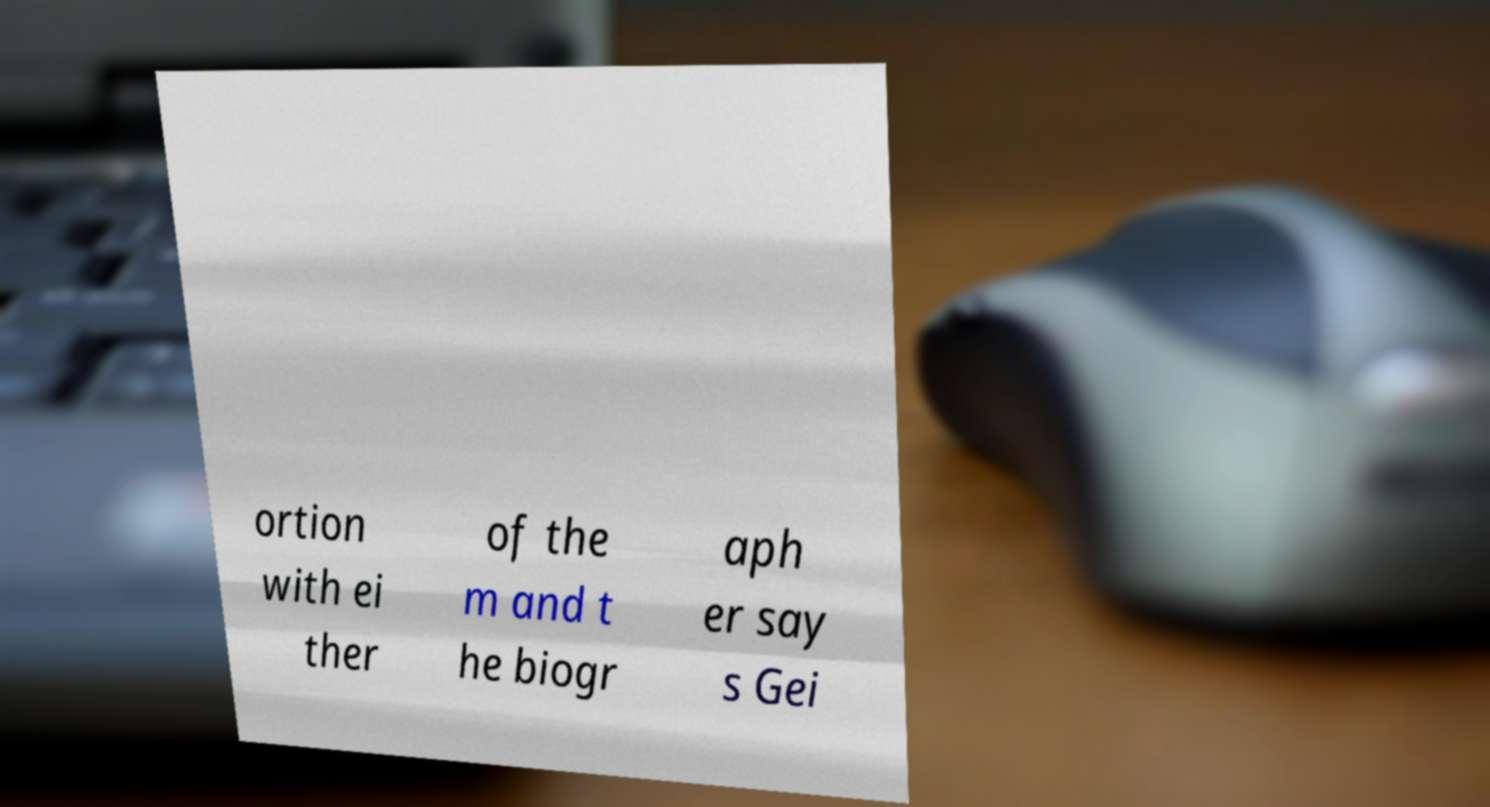What messages or text are displayed in this image? I need them in a readable, typed format. ortion with ei ther of the m and t he biogr aph er say s Gei 